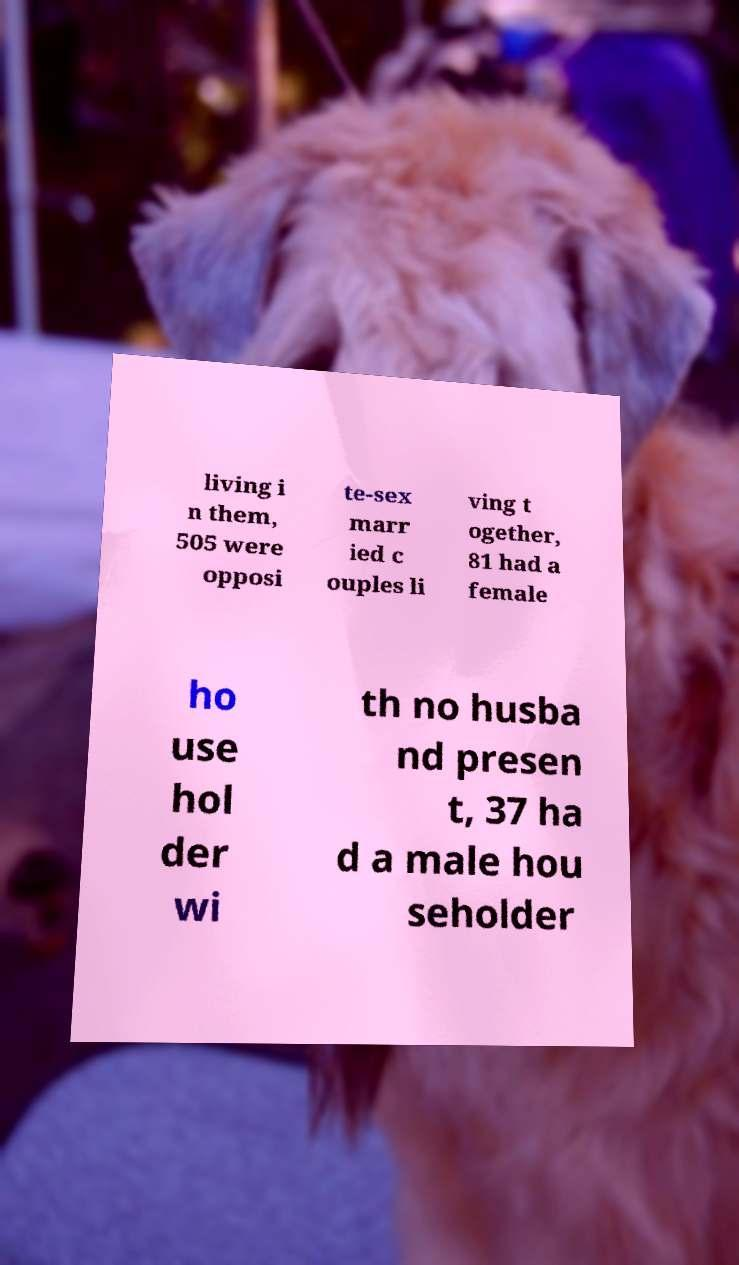Could you assist in decoding the text presented in this image and type it out clearly? living i n them, 505 were opposi te-sex marr ied c ouples li ving t ogether, 81 had a female ho use hol der wi th no husba nd presen t, 37 ha d a male hou seholder 